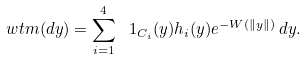<formula> <loc_0><loc_0><loc_500><loc_500>\ w t m ( d y ) = \sum _ { i = 1 } ^ { 4 } \ 1 _ { C _ { i } } ( y ) h _ { i } ( y ) e ^ { - W ( \| y \| ) } \, d y .</formula> 